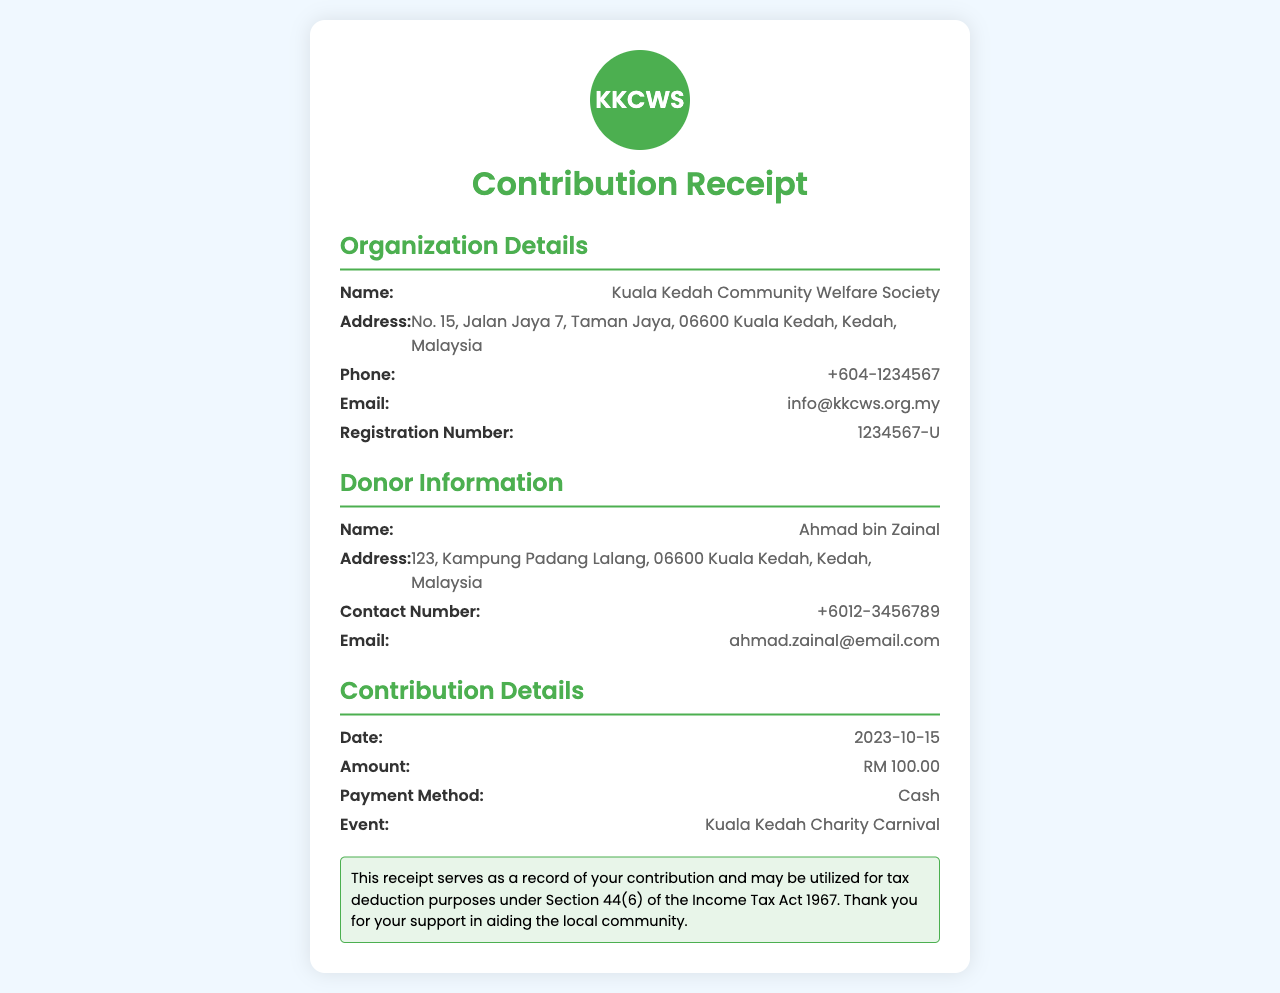What is the name of the organization? The organization name is displayed prominently at the top of the receipt.
Answer: Kuala Kedah Community Welfare Society What is the registration number? The registration number of the organization is listed under the organization details.
Answer: 1234567-U What is the amount contributed? The contribution details specify the amount donated by the donor.
Answer: RM 100.00 Who is the donor? The donor's name is provided in the donor information section.
Answer: Ahmad bin Zainal What is the date of the contribution? The date of the contribution is mentioned in the contribution details.
Answer: 2023-10-15 What event is this contribution for? The event for which the donation is made is specified in the contribution details section.
Answer: Kuala Kedah Charity Carnival What payment method was used? The method of payment for the contribution is noted in the contribution details.
Answer: Cash Is this receipt tax-deductible? The receipt includes a statement regarding its use for tax deduction purposes.
Answer: Yes What is the email of the organization? The email address for the organization is found in the organization details.
Answer: info@kkcws.org.my 